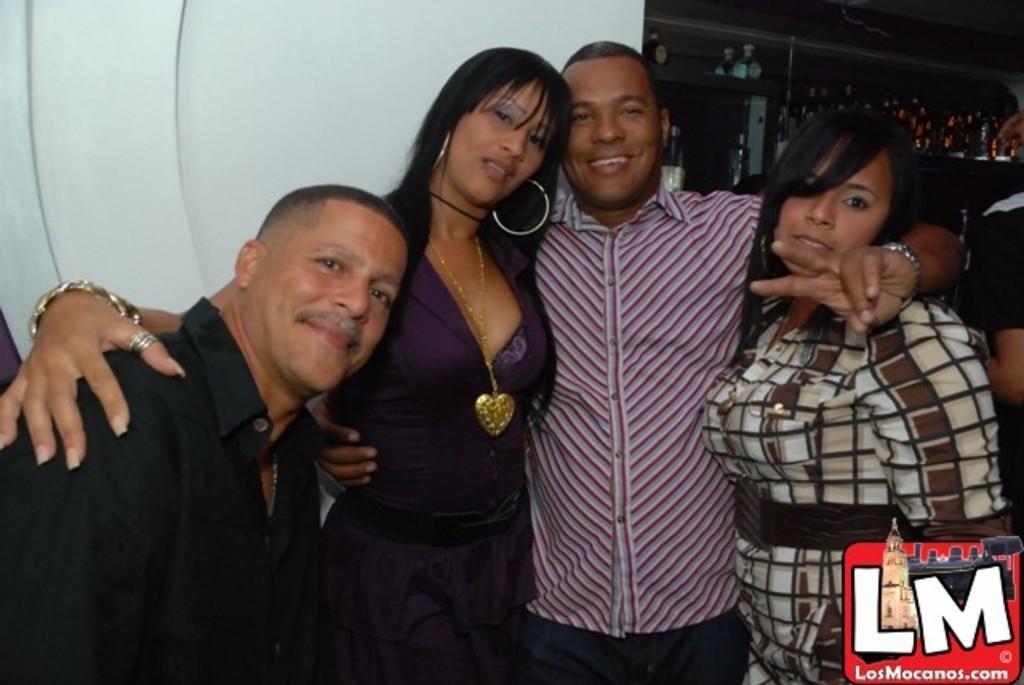In one or two sentences, can you explain what this image depicts? In this picture I can see four persons, there are glass bottles and some other objects in a cupboard, and in the background there is a wall and there is a watermark on the image. 